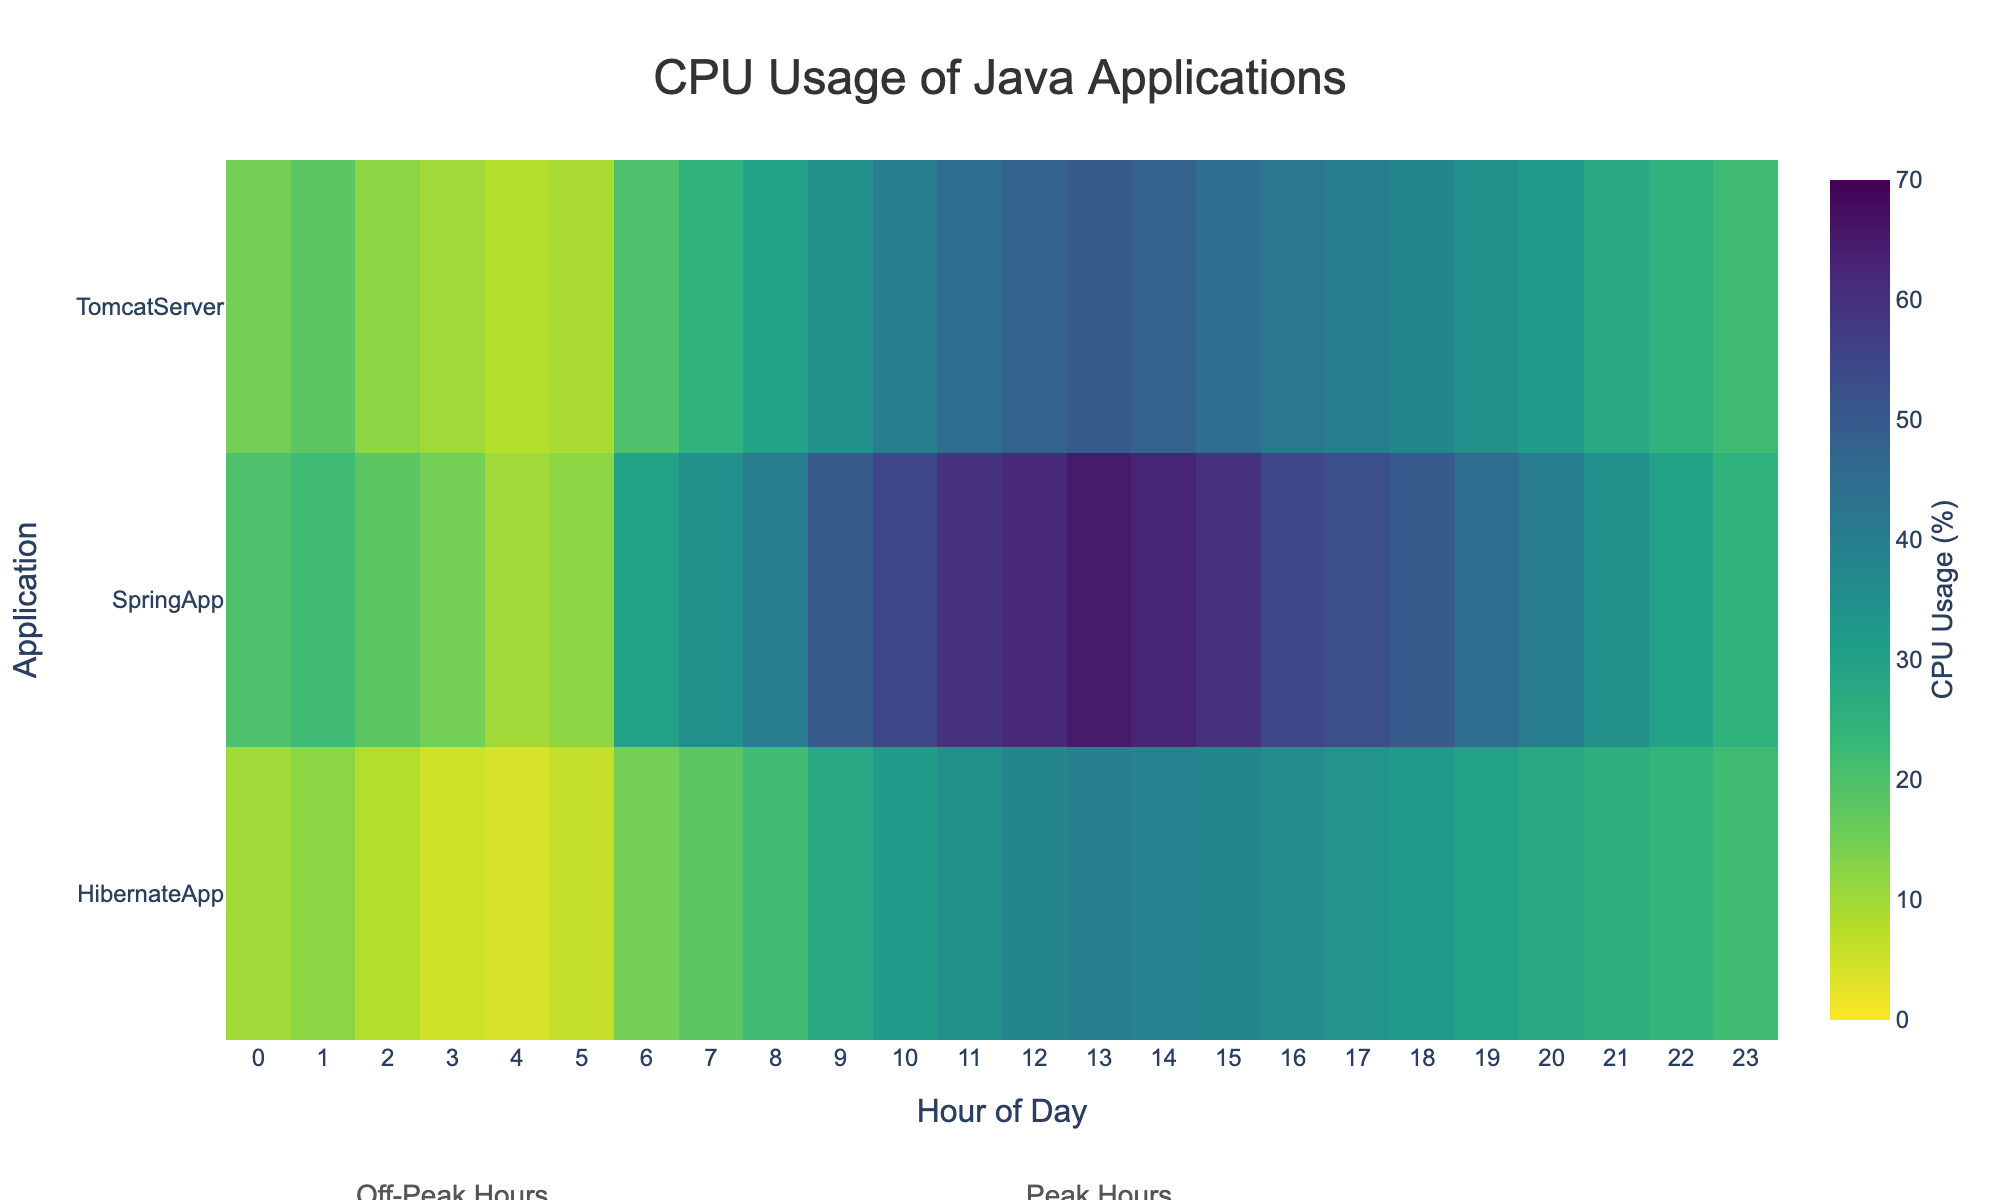What is the title of the heatmap? The title of the plot is displayed at the top center of the heatmap.
Answer: CPU Usage of Java Applications What does the color bar represent? The color bar indicates the range of CPU usage percentages, with a gradient color scale from low (light green) to high (dark purple).
Answer: CPU Usage (%) What is the CPU usage of the SpringApp at 12 PM? Locate the intersection of the "SpringApp" row and "12" column to find the corresponding cell value.
Answer: 62% During which hour does the TomcatServer reach its peak CPU usage? Observe the "TomcatServer" row and identify the highest value.
Answer: 1 PM How does the CPU usage of HibernateApp change from 10 AM to 4 PM? Examine the values in the "HibernateApp" row from 10 AM to 4 PM.
Answer: It increases from 32% at 10 AM to 40% at 1 PM, then slightly decreases to 36% by 4 PM Which application shows the highest overall CPU usage during peak hours (8 AM to 6 PM)? Look at the CPU values between 8 AM and 6 PM for all applications and identify the maximum value.
Answer: SpringApp How do the peak hours differ from the off-peak hours in terms of CPU usage for SpringApp? Compare the CPU usage values of SpringApp during off-peak (0-6 AM) and peak (8 AM - 6 PM) hours.
Answer: Significantly higher during peak hours What are the average CPU usage values for each application during off-peak hours (0-6 AM)? Calculate the average CPU usage from 0-6 AM for each application by summing the values and dividing by the number of data points.
Answer: SpringApp: 19.5%, HibernateApp: 7.5%, TomcatServer: 15.33% Which application has the most consistent (least variable) CPU usage throughout the day? Examine the range and fluctuation of CPU usage values across all hours for each application.
Answer: HibernateApp How much higher is the average CPU usage of SpringApp than HibernateApp during peak hours? Calculate the average CPU usage of both applications during peak hours, then subtract HibernateApp's average from SpringApp's.
Answer: 62.36% - 33.27% = 29.09% 